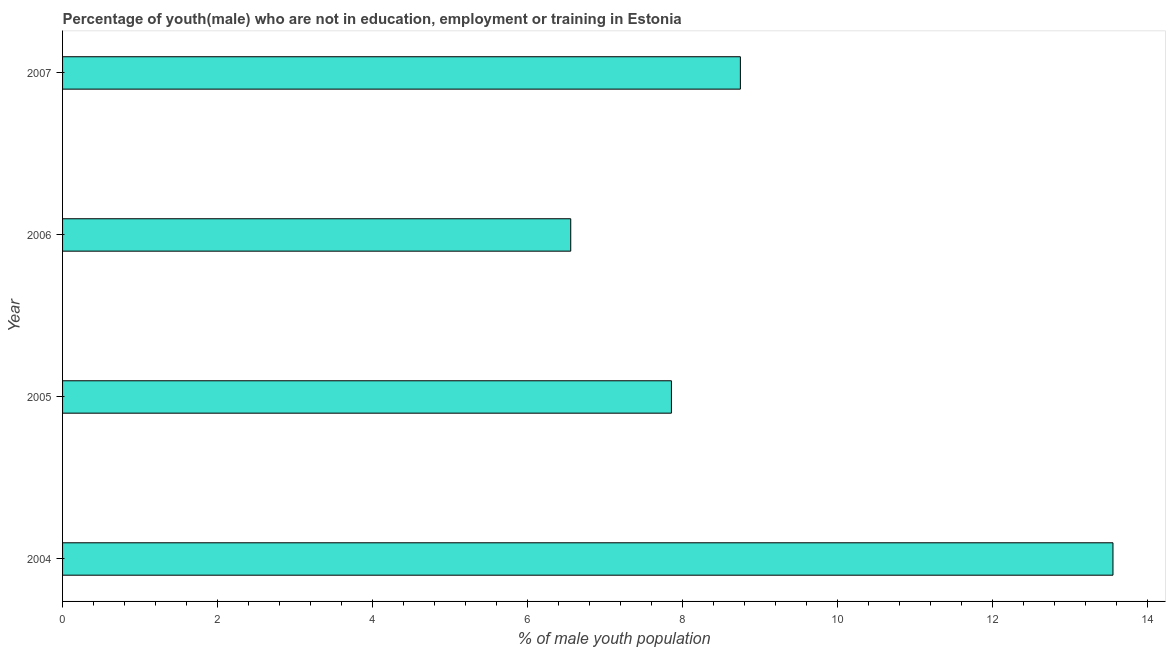What is the title of the graph?
Give a very brief answer. Percentage of youth(male) who are not in education, employment or training in Estonia. What is the label or title of the X-axis?
Provide a short and direct response. % of male youth population. What is the unemployed male youth population in 2006?
Keep it short and to the point. 6.56. Across all years, what is the maximum unemployed male youth population?
Provide a succinct answer. 13.56. Across all years, what is the minimum unemployed male youth population?
Make the answer very short. 6.56. In which year was the unemployed male youth population maximum?
Keep it short and to the point. 2004. What is the sum of the unemployed male youth population?
Give a very brief answer. 36.73. What is the difference between the unemployed male youth population in 2004 and 2006?
Make the answer very short. 7. What is the average unemployed male youth population per year?
Your response must be concise. 9.18. What is the median unemployed male youth population?
Provide a succinct answer. 8.31. What is the ratio of the unemployed male youth population in 2006 to that in 2007?
Offer a very short reply. 0.75. Is the difference between the unemployed male youth population in 2005 and 2006 greater than the difference between any two years?
Keep it short and to the point. No. What is the difference between the highest and the second highest unemployed male youth population?
Keep it short and to the point. 4.81. What is the difference between the highest and the lowest unemployed male youth population?
Offer a very short reply. 7. How many years are there in the graph?
Make the answer very short. 4. What is the difference between two consecutive major ticks on the X-axis?
Give a very brief answer. 2. Are the values on the major ticks of X-axis written in scientific E-notation?
Keep it short and to the point. No. What is the % of male youth population in 2004?
Offer a very short reply. 13.56. What is the % of male youth population of 2005?
Your answer should be very brief. 7.86. What is the % of male youth population of 2006?
Offer a terse response. 6.56. What is the % of male youth population in 2007?
Your answer should be compact. 8.75. What is the difference between the % of male youth population in 2004 and 2005?
Your answer should be compact. 5.7. What is the difference between the % of male youth population in 2004 and 2007?
Offer a very short reply. 4.81. What is the difference between the % of male youth population in 2005 and 2006?
Offer a terse response. 1.3. What is the difference between the % of male youth population in 2005 and 2007?
Offer a terse response. -0.89. What is the difference between the % of male youth population in 2006 and 2007?
Keep it short and to the point. -2.19. What is the ratio of the % of male youth population in 2004 to that in 2005?
Provide a succinct answer. 1.73. What is the ratio of the % of male youth population in 2004 to that in 2006?
Offer a terse response. 2.07. What is the ratio of the % of male youth population in 2004 to that in 2007?
Provide a succinct answer. 1.55. What is the ratio of the % of male youth population in 2005 to that in 2006?
Make the answer very short. 1.2. What is the ratio of the % of male youth population in 2005 to that in 2007?
Keep it short and to the point. 0.9. What is the ratio of the % of male youth population in 2006 to that in 2007?
Keep it short and to the point. 0.75. 